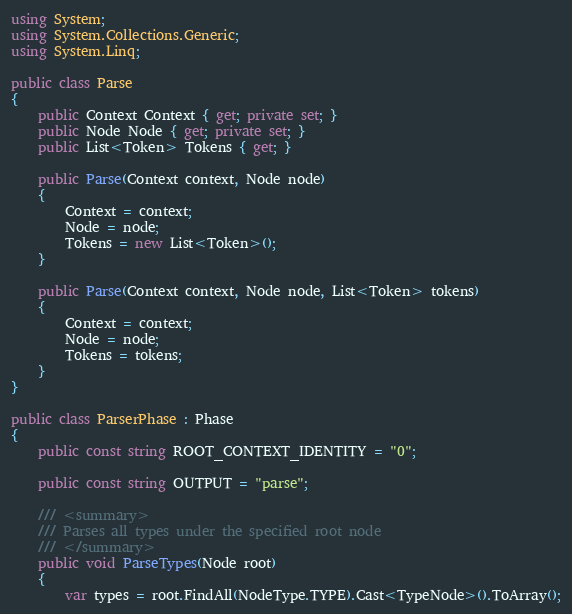<code> <loc_0><loc_0><loc_500><loc_500><_C#_>using System;
using System.Collections.Generic;
using System.Linq;

public class Parse
{
	public Context Context { get; private set; }
	public Node Node { get; private set; }
	public List<Token> Tokens { get; }

	public Parse(Context context, Node node)
	{
		Context = context;
		Node = node;
		Tokens = new List<Token>();
	}

	public Parse(Context context, Node node, List<Token> tokens)
	{
		Context = context;
		Node = node;
		Tokens = tokens;
	}
}

public class ParserPhase : Phase
{
	public const string ROOT_CONTEXT_IDENTITY = "0";

	public const string OUTPUT = "parse";

	/// <summary>
	/// Parses all types under the specified root node
	/// </summary>
	public void ParseTypes(Node root)
	{
		var types = root.FindAll(NodeType.TYPE).Cast<TypeNode>().ToArray();
</code> 